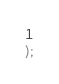<code> <loc_0><loc_0><loc_500><loc_500><_SQL_>1
);</code> 